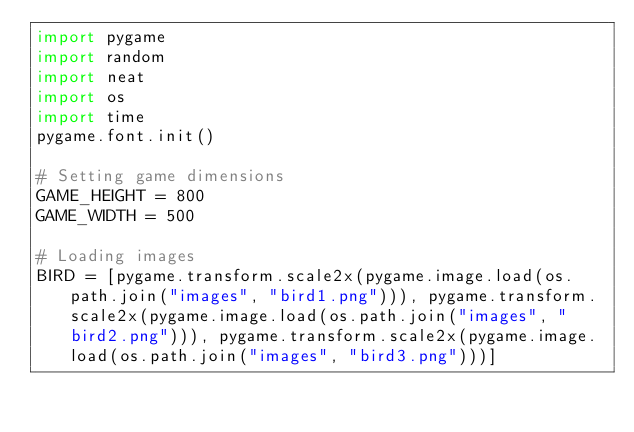Convert code to text. <code><loc_0><loc_0><loc_500><loc_500><_Python_>import pygame
import random
import neat
import os
import time
pygame.font.init()

# Setting game dimensions
GAME_HEIGHT = 800
GAME_WIDTH = 500

# Loading images
BIRD = [pygame.transform.scale2x(pygame.image.load(os.path.join("images", "bird1.png"))), pygame.transform.scale2x(pygame.image.load(os.path.join("images", "bird2.png"))), pygame.transform.scale2x(pygame.image.load(os.path.join("images", "bird3.png")))]</code> 